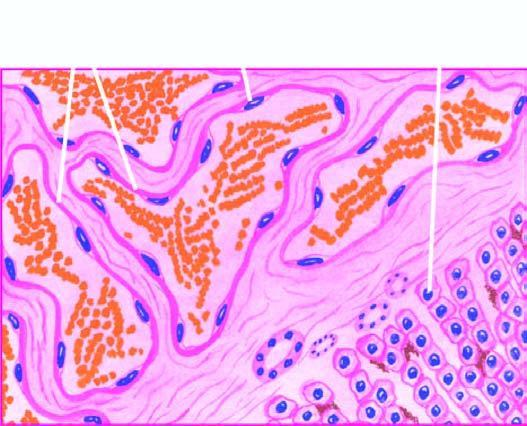re the vascular spaces large, dilated, many containing blood, and are lined by flattened endothelial cells?
Answer the question using a single word or phrase. Yes 